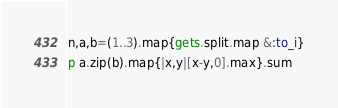Convert code to text. <code><loc_0><loc_0><loc_500><loc_500><_Crystal_>n,a,b=(1..3).map{gets.split.map &:to_i}
p a.zip(b).map{|x,y|[x-y,0].max}.sum</code> 